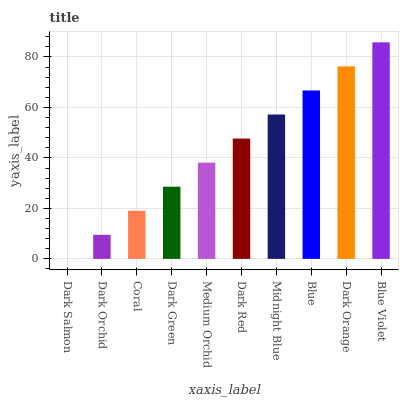Is Dark Orchid the minimum?
Answer yes or no. No. Is Dark Orchid the maximum?
Answer yes or no. No. Is Dark Orchid greater than Dark Salmon?
Answer yes or no. Yes. Is Dark Salmon less than Dark Orchid?
Answer yes or no. Yes. Is Dark Salmon greater than Dark Orchid?
Answer yes or no. No. Is Dark Orchid less than Dark Salmon?
Answer yes or no. No. Is Dark Red the high median?
Answer yes or no. Yes. Is Medium Orchid the low median?
Answer yes or no. Yes. Is Dark Orchid the high median?
Answer yes or no. No. Is Dark Orchid the low median?
Answer yes or no. No. 